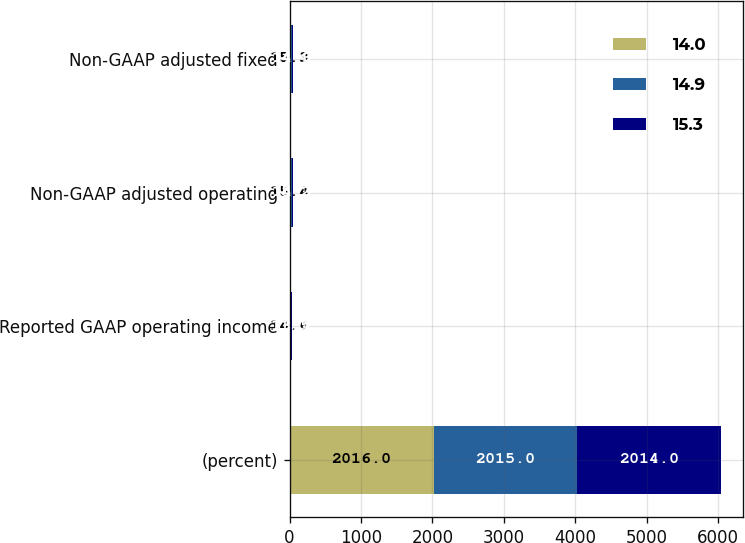<chart> <loc_0><loc_0><loc_500><loc_500><stacked_bar_chart><ecel><fcel>(percent)<fcel>Reported GAAP operating income<fcel>Non-GAAP adjusted operating<fcel>Non-GAAP adjusted fixed<nl><fcel>14<fcel>2016<fcel>14.6<fcel>15.4<fcel>15.3<nl><fcel>14.9<fcel>2015<fcel>11.5<fcel>15.2<fcel>14.9<nl><fcel>15.3<fcel>2014<fcel>13.7<fcel>14.3<fcel>14<nl></chart> 